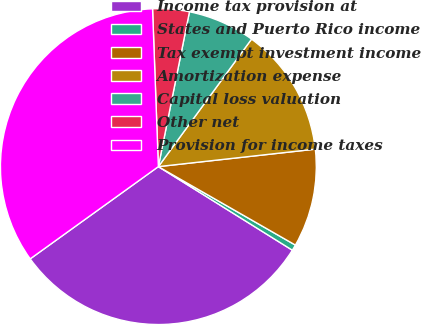Convert chart. <chart><loc_0><loc_0><loc_500><loc_500><pie_chart><fcel>Income tax provision at<fcel>States and Puerto Rico income<fcel>Tax exempt investment income<fcel>Amortization expense<fcel>Capital loss valuation<fcel>Other net<fcel>Provision for income taxes<nl><fcel>31.19%<fcel>0.6%<fcel>10.04%<fcel>13.19%<fcel>6.89%<fcel>3.74%<fcel>34.34%<nl></chart> 